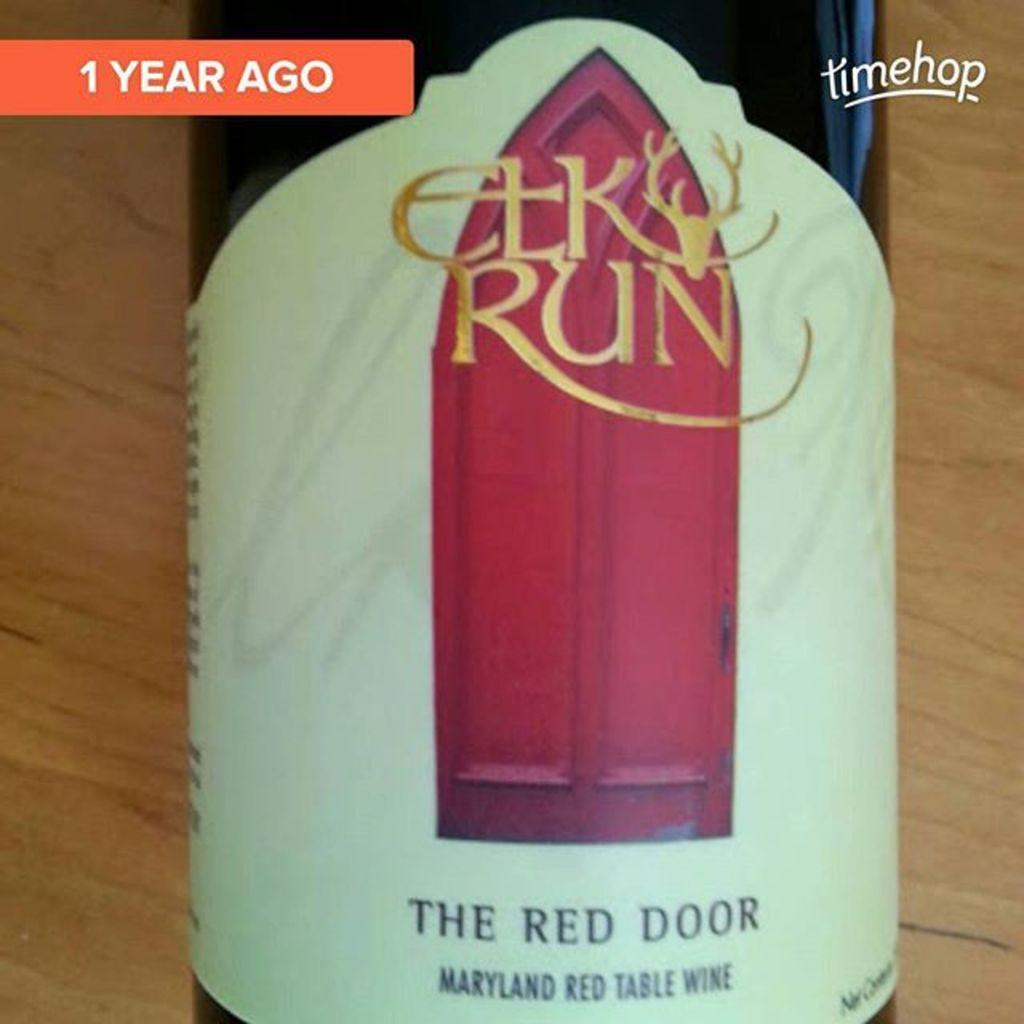<image>
Summarize the visual content of the image. the front of a bottle of elk run the red door Maryland red table wind with a red door on the front . 